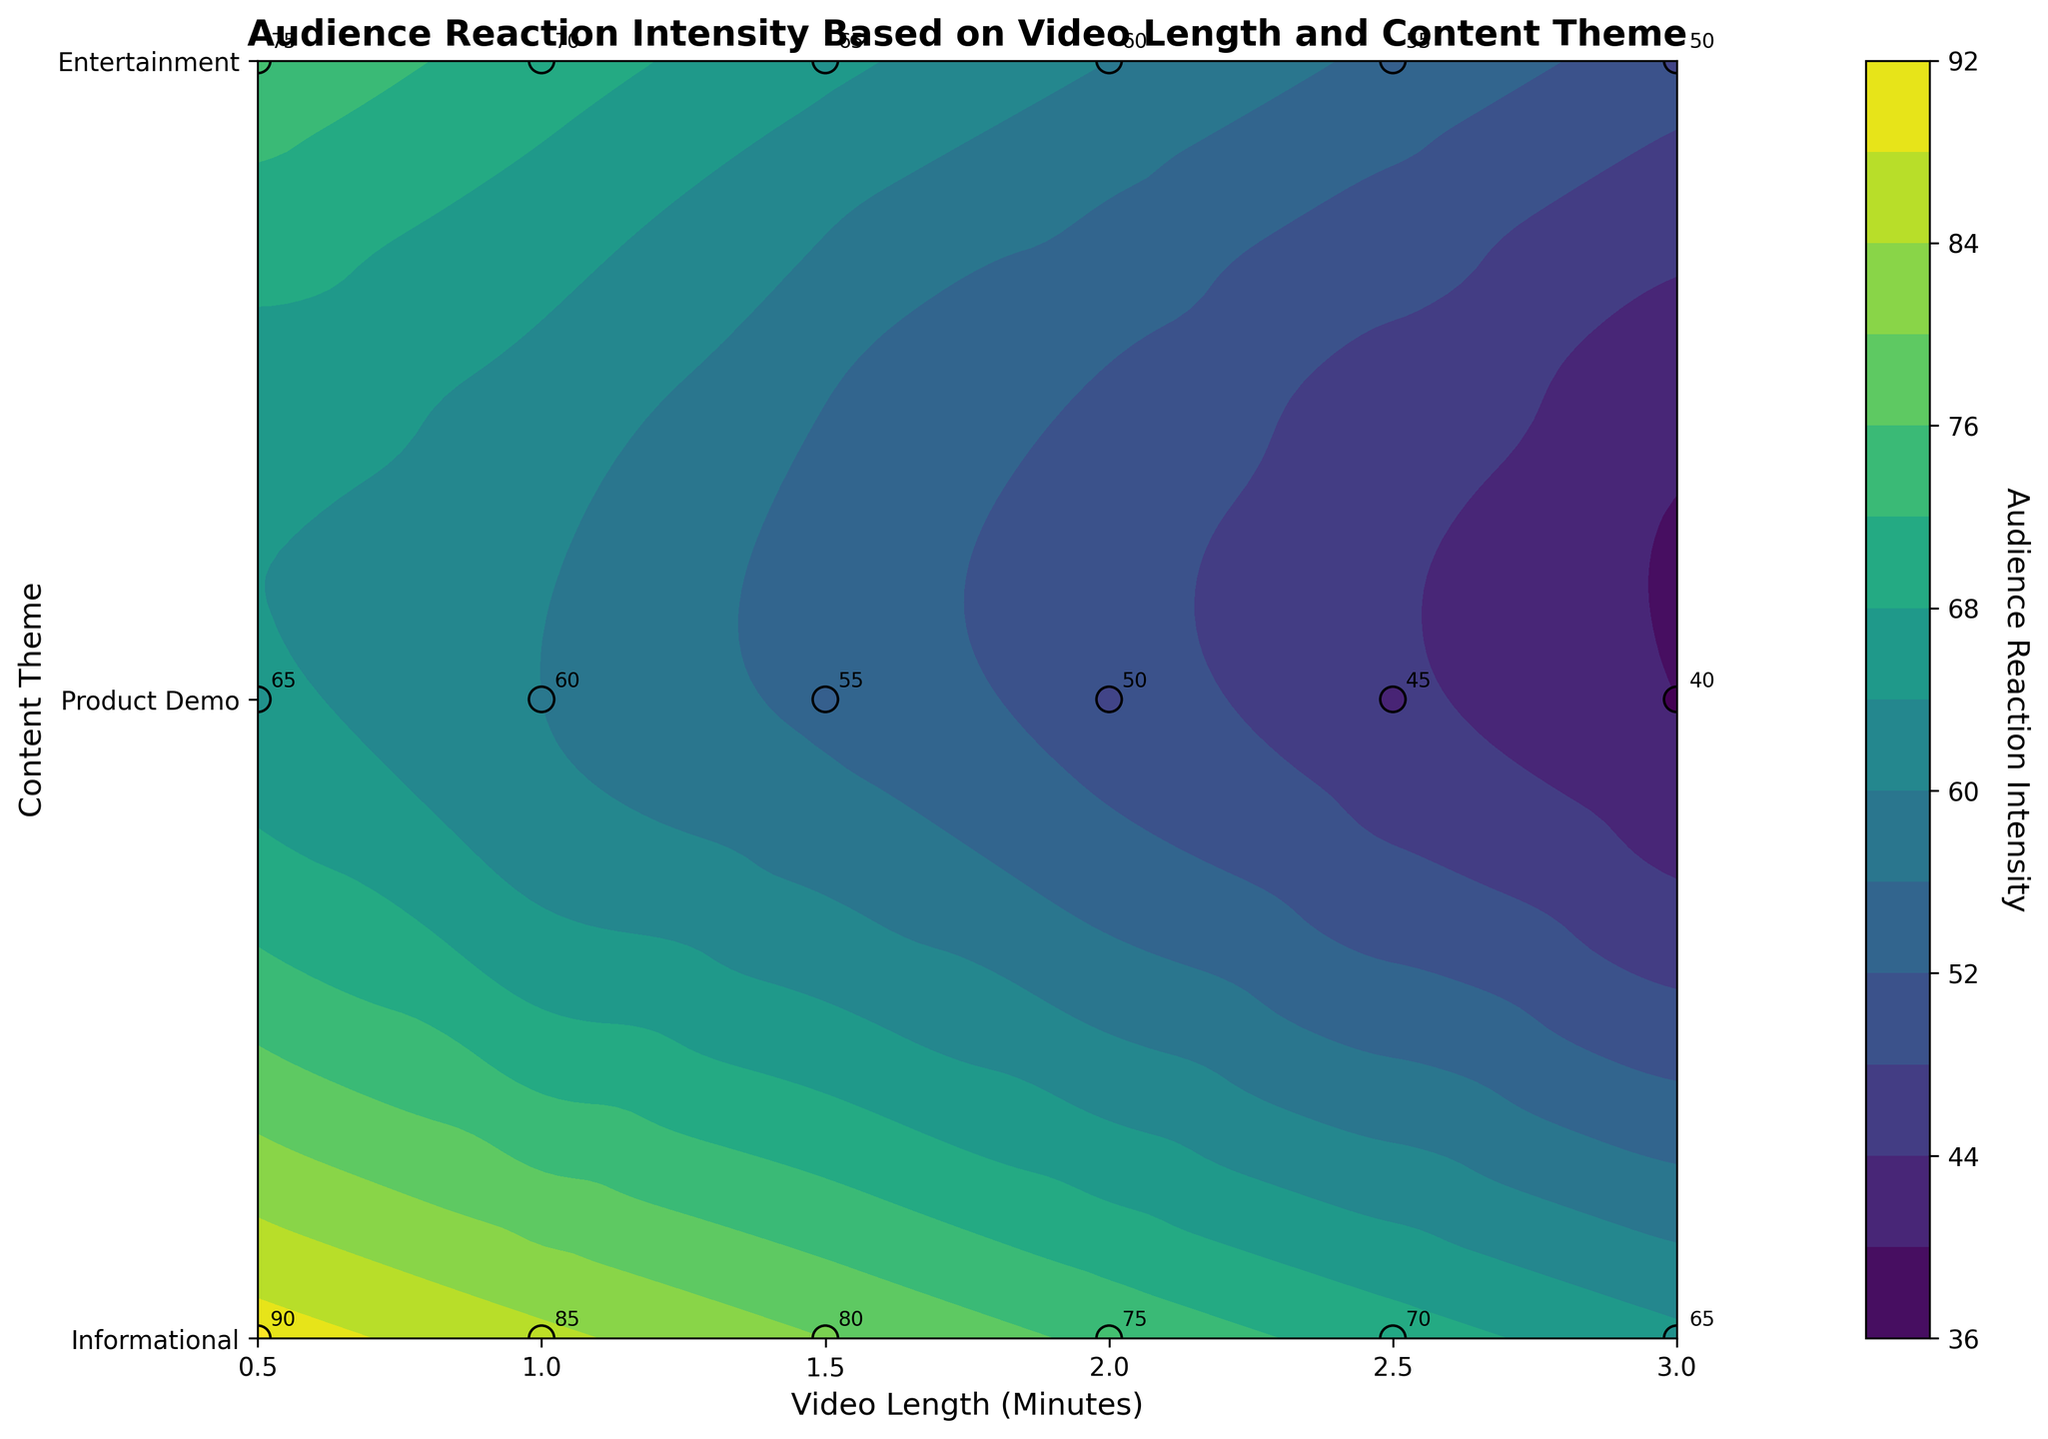What is the title of the plot? The title of the plot is presented at the top of the figure. It reads "Audience Reaction Intensity Based on Video Length and Content Theme".
Answer: Audience Reaction Intensity Based on Video Length and Content Theme Which content theme has the highest audience reaction intensity for the shortest video length? By looking at the y-axis for the content theme and the x-axis for the shortest video length (0.5 minutes), the highest audience reaction intensity is marked at the point for the Entertainment theme.
Answer: Entertainment What are the axis labels? The x-axis label reads "Video Length (Minutes)" and the y-axis label reads "Content Theme". These labels are visible along the respective axes.
Answer: "Video Length (Minutes)" and "Content Theme" How many content themes were evaluated? The y-axis ticks and labels indicate three distinct content themes used for evaluation: Informational, Product Demo, and Entertainment.
Answer: 3 Which content theme shows the lowest audience reaction intensity at 2.0 minutes? Observing the color and annotated numbers at 2.0 minutes on the x-axis, the lowest reaction intensity is marked for the Informational theme.
Answer: Informational What is the general trend of audience reaction intensity as the video length increases for Product Demo content? By tracking the Product Demo content theme along the y-axis and moving across the x-axis for increasing video lengths, it is observed that the audience reaction intensity generally decreases.
Answer: Decreases What's the difference in reaction intensity between the shortest and longest Entertainment videos? The shortest Entertainment video (0.5 minutes) has an intensity of 90, and the longest (3.0 minutes) has an intensity of 65. The difference is 90 - 65.
Answer: 25 Which combination of video length and content theme has the highest audience reaction intensity? By observing the annotated values, the highest intensity is marked at 0.5 minutes for the Entertainment theme, with a value of 90.
Answer: 0.5 minutes, Entertainment How does the audience reaction intensity for Informational videos change with increasing length? Observing the points for Informational content across the increasing video lengths on the x-axis, the audience reaction intensity decreases progressively from 65 to 40.
Answer: Decreases Which content theme maintains a relatively high audience reaction intensity across different video lengths? By comparing the color gradients and annotated values, the Entertainment theme consistently shows relatively high intensity values from 90 at 0.5 minutes to 65 at 3.0 minutes.
Answer: Entertainment 